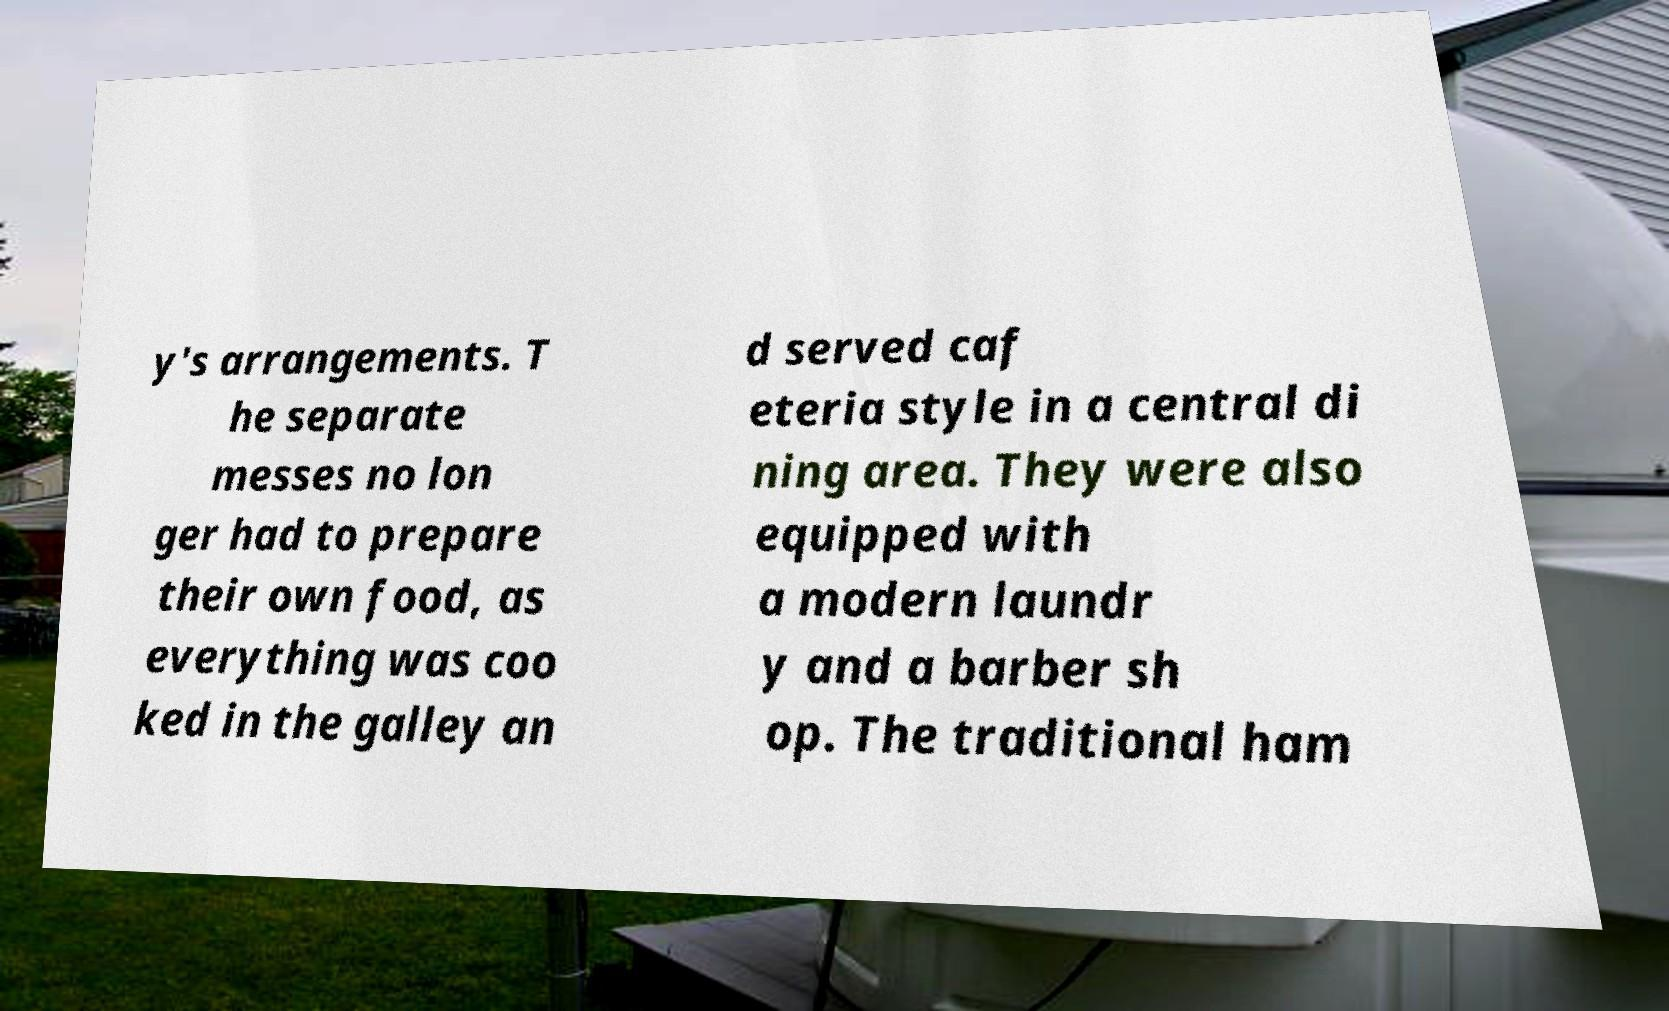What messages or text are displayed in this image? I need them in a readable, typed format. y's arrangements. T he separate messes no lon ger had to prepare their own food, as everything was coo ked in the galley an d served caf eteria style in a central di ning area. They were also equipped with a modern laundr y and a barber sh op. The traditional ham 